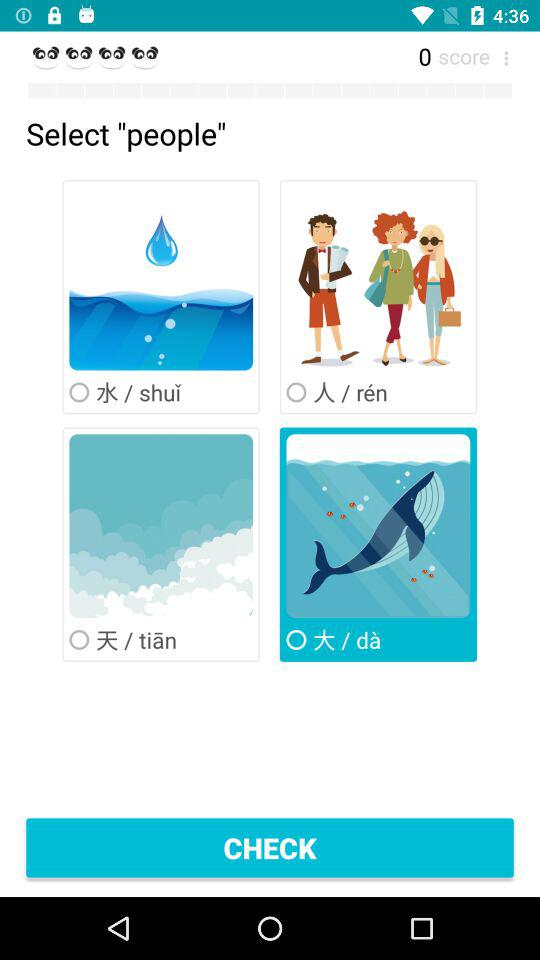What's the score? The score is 0. 